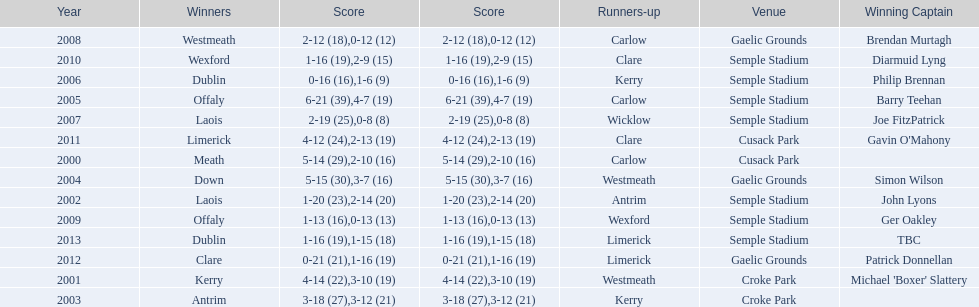Would you be able to parse every entry in this table? {'header': ['Year', 'Winners', 'Score', 'Score', 'Runners-up', 'Venue', 'Winning Captain'], 'rows': [['2008', 'Westmeath', '2-12 (18)', '0-12 (12)', 'Carlow', 'Gaelic Grounds', 'Brendan Murtagh'], ['2010', 'Wexford', '1-16 (19)', '2-9 (15)', 'Clare', 'Semple Stadium', 'Diarmuid Lyng'], ['2006', 'Dublin', '0-16 (16)', '1-6 (9)', 'Kerry', 'Semple Stadium', 'Philip Brennan'], ['2005', 'Offaly', '6-21 (39)', '4-7 (19)', 'Carlow', 'Semple Stadium', 'Barry Teehan'], ['2007', 'Laois', '2-19 (25)', '0-8 (8)', 'Wicklow', 'Semple Stadium', 'Joe FitzPatrick'], ['2011', 'Limerick', '4-12 (24)', '2-13 (19)', 'Clare', 'Cusack Park', "Gavin O'Mahony"], ['2000', 'Meath', '5-14 (29)', '2-10 (16)', 'Carlow', 'Cusack Park', ''], ['2004', 'Down', '5-15 (30)', '3-7 (16)', 'Westmeath', 'Gaelic Grounds', 'Simon Wilson'], ['2002', 'Laois', '1-20 (23)', '2-14 (20)', 'Antrim', 'Semple Stadium', 'John Lyons'], ['2009', 'Offaly', '1-13 (16)', '0-13 (13)', 'Wexford', 'Semple Stadium', 'Ger Oakley'], ['2013', 'Dublin', '1-16 (19)', '1-15 (18)', 'Limerick', 'Semple Stadium', 'TBC'], ['2012', 'Clare', '0-21 (21)', '1-16 (19)', 'Limerick', 'Gaelic Grounds', 'Patrick Donnellan'], ['2001', 'Kerry', '4-14 (22)', '3-10 (19)', 'Westmeath', 'Croke Park', "Michael 'Boxer' Slattery"], ['2003', 'Antrim', '3-18 (27)', '3-12 (21)', 'Kerry', 'Croke Park', '']]} What is the overall sum of instances the event occurred at the semple stadium site? 7. 